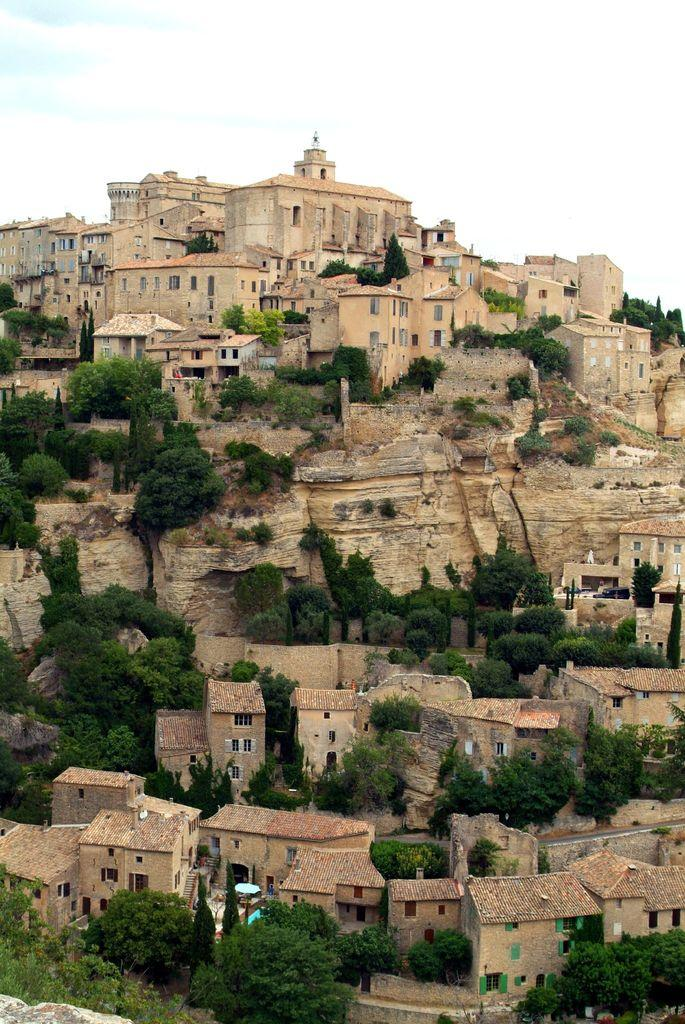What type of vegetation is present in the image? There are trees in the image. What type of structures can be seen in the image? There are houses in the image. How long does it take for the boy to finish his history homework in the image? There is no boy or mention of homework in the image; it only features trees and houses. 